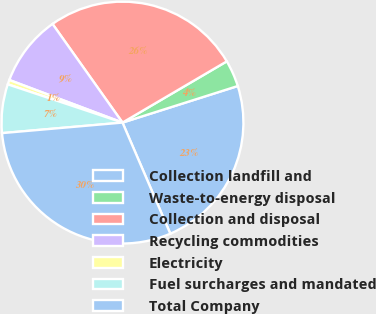<chart> <loc_0><loc_0><loc_500><loc_500><pie_chart><fcel>Collection landfill and<fcel>Waste-to-energy disposal<fcel>Collection and disposal<fcel>Recycling commodities<fcel>Electricity<fcel>Fuel surcharges and mandated<fcel>Total Company<nl><fcel>23.42%<fcel>3.56%<fcel>26.37%<fcel>9.45%<fcel>0.61%<fcel>6.51%<fcel>30.08%<nl></chart> 